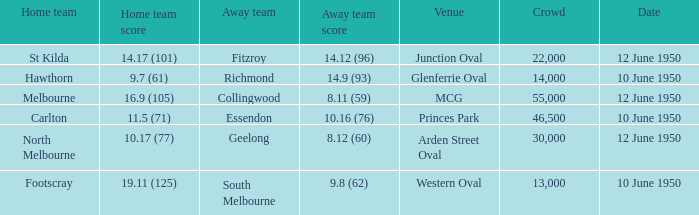Who was the away team when the VFL played at MCG? Collingwood. 